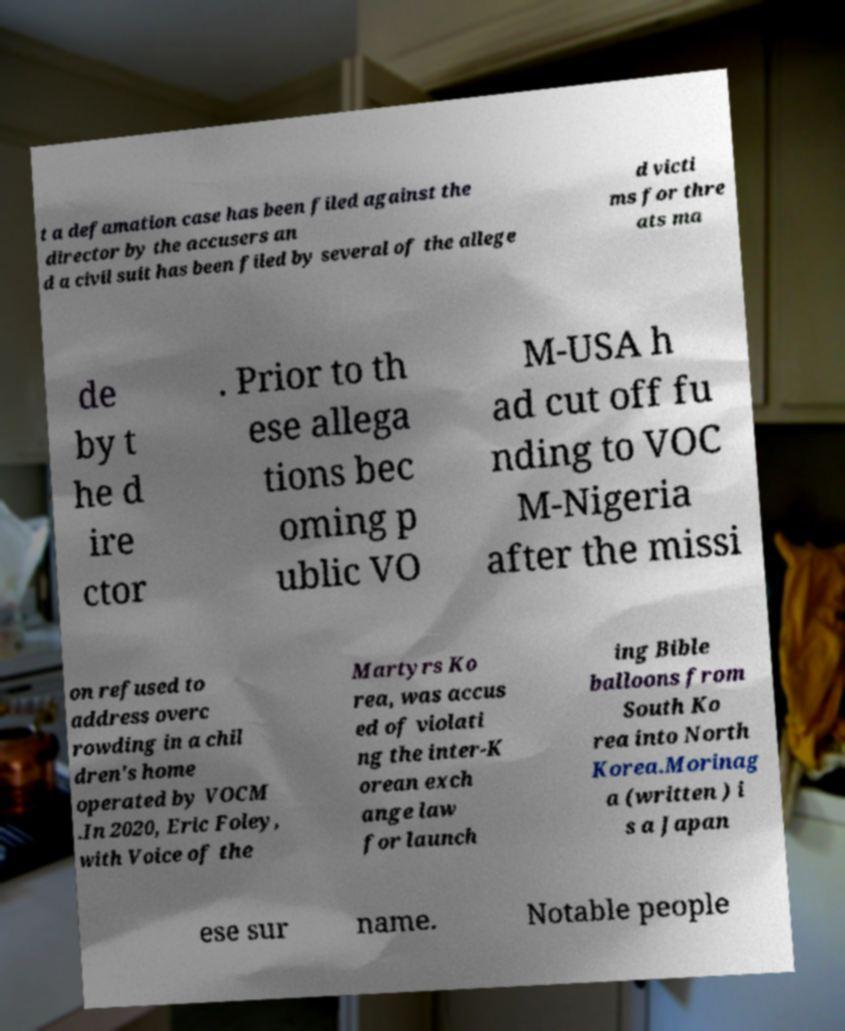What messages or text are displayed in this image? I need them in a readable, typed format. t a defamation case has been filed against the director by the accusers an d a civil suit has been filed by several of the allege d victi ms for thre ats ma de by t he d ire ctor . Prior to th ese allega tions bec oming p ublic VO M-USA h ad cut off fu nding to VOC M-Nigeria after the missi on refused to address overc rowding in a chil dren's home operated by VOCM .In 2020, Eric Foley, with Voice of the Martyrs Ko rea, was accus ed of violati ng the inter-K orean exch ange law for launch ing Bible balloons from South Ko rea into North Korea.Morinag a (written ) i s a Japan ese sur name. Notable people 